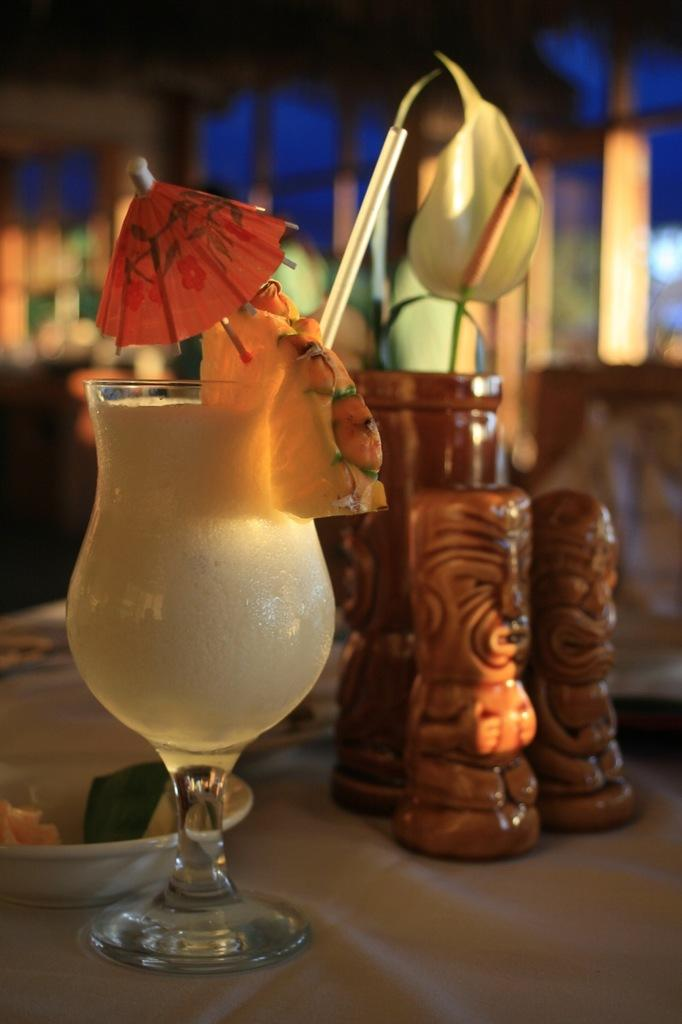What objects can be seen in the image? There are toys, a bowl, and a glass with a drink and a straw in the image. What might be used for holding or serving food in the image? The bowl can be used for holding or serving food. What is the glass in the image used for? The glass in the image is used for holding a drink, with a straw for drinking. How would you describe the background of the image? The background of the image is blurry. What type of crow is singing a song in the image? There is no crow or song present in the image; it features toys, a bowl, and a glass with a drink and a straw. How much dust can be seen on the toys in the image? There is no mention of dust in the image, and the toys do not appear to be dusty. 